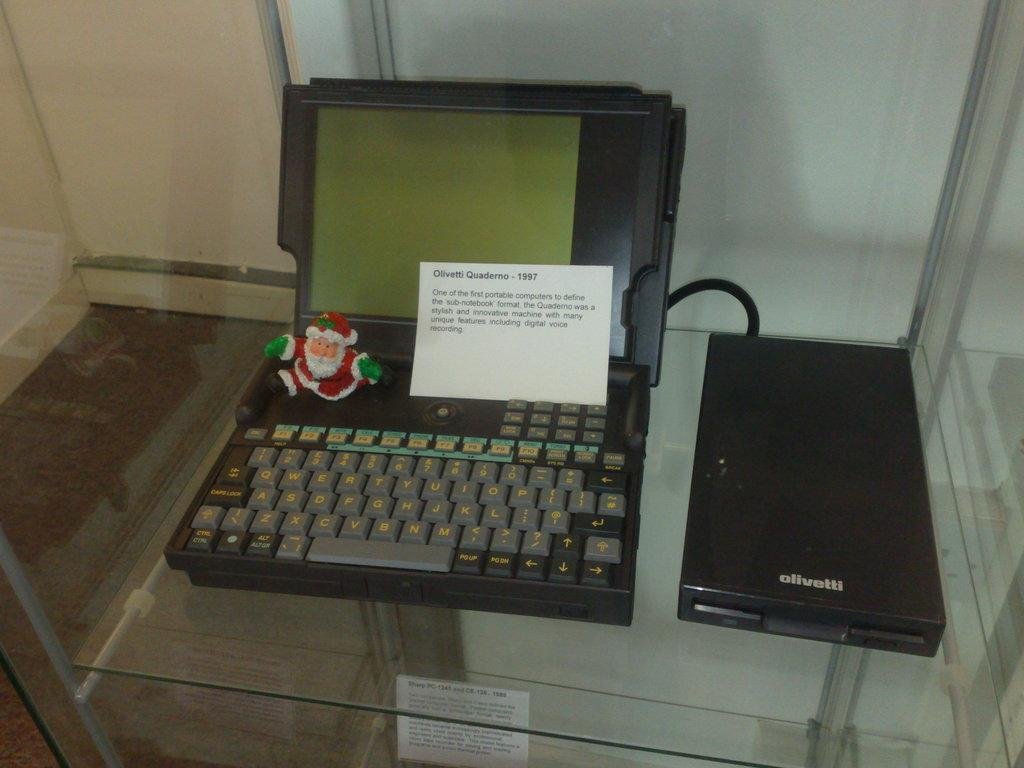<image>
Relay a brief, clear account of the picture shown. One of the first sub-notebook Quadermo portable computer 